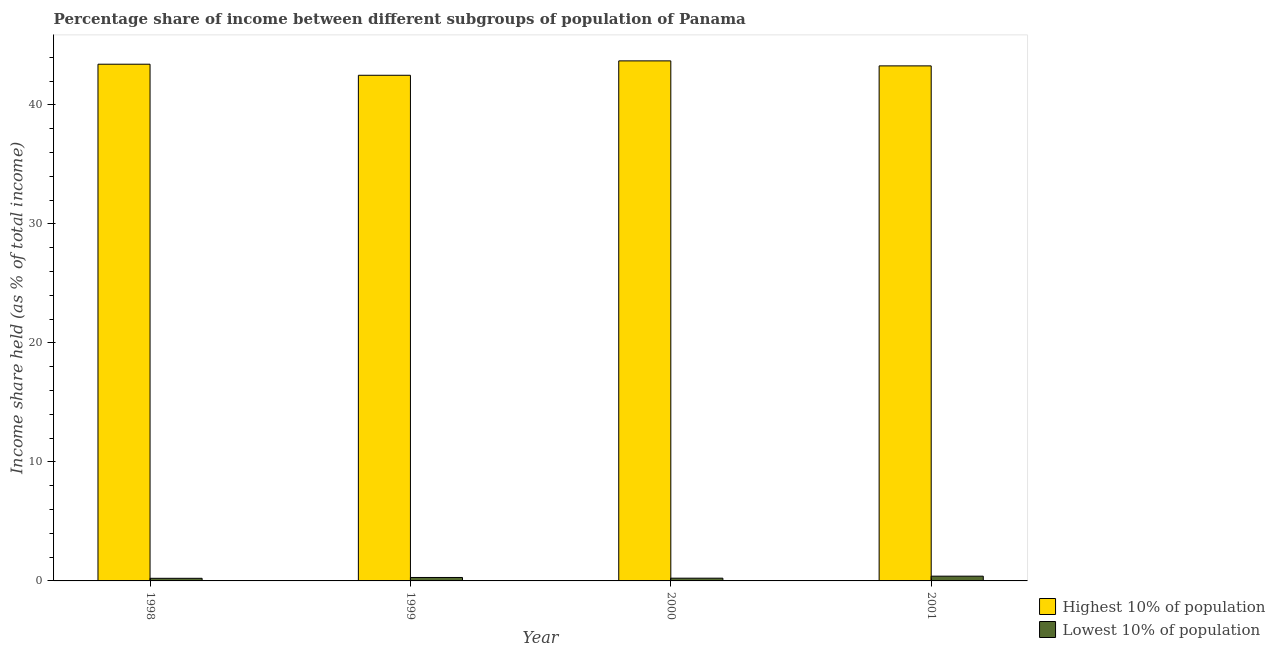How many different coloured bars are there?
Offer a terse response. 2. Are the number of bars on each tick of the X-axis equal?
Ensure brevity in your answer.  Yes. Across all years, what is the maximum income share held by highest 10% of the population?
Your response must be concise. 43.7. Across all years, what is the minimum income share held by highest 10% of the population?
Give a very brief answer. 42.49. In which year was the income share held by lowest 10% of the population maximum?
Keep it short and to the point. 2001. In which year was the income share held by highest 10% of the population minimum?
Make the answer very short. 1999. What is the total income share held by lowest 10% of the population in the graph?
Offer a very short reply. 1.14. What is the difference between the income share held by lowest 10% of the population in 1998 and that in 2000?
Your answer should be very brief. -0.01. What is the difference between the income share held by lowest 10% of the population in 1998 and the income share held by highest 10% of the population in 2000?
Keep it short and to the point. -0.01. What is the average income share held by highest 10% of the population per year?
Provide a succinct answer. 43.22. What is the ratio of the income share held by highest 10% of the population in 1998 to that in 2001?
Provide a short and direct response. 1. Is the income share held by highest 10% of the population in 2000 less than that in 2001?
Ensure brevity in your answer.  No. Is the difference between the income share held by lowest 10% of the population in 1999 and 2000 greater than the difference between the income share held by highest 10% of the population in 1999 and 2000?
Your answer should be very brief. No. What is the difference between the highest and the second highest income share held by lowest 10% of the population?
Ensure brevity in your answer.  0.11. What is the difference between the highest and the lowest income share held by highest 10% of the population?
Provide a succinct answer. 1.21. In how many years, is the income share held by highest 10% of the population greater than the average income share held by highest 10% of the population taken over all years?
Offer a terse response. 3. What does the 2nd bar from the left in 2000 represents?
Offer a very short reply. Lowest 10% of population. What does the 1st bar from the right in 2000 represents?
Provide a succinct answer. Lowest 10% of population. How many bars are there?
Your answer should be very brief. 8. Are all the bars in the graph horizontal?
Offer a terse response. No. How many legend labels are there?
Give a very brief answer. 2. How are the legend labels stacked?
Your answer should be very brief. Vertical. What is the title of the graph?
Your response must be concise. Percentage share of income between different subgroups of population of Panama. What is the label or title of the Y-axis?
Provide a short and direct response. Income share held (as % of total income). What is the Income share held (as % of total income) in Highest 10% of population in 1998?
Offer a very short reply. 43.42. What is the Income share held (as % of total income) of Lowest 10% of population in 1998?
Your answer should be very brief. 0.22. What is the Income share held (as % of total income) of Highest 10% of population in 1999?
Your answer should be compact. 42.49. What is the Income share held (as % of total income) of Lowest 10% of population in 1999?
Keep it short and to the point. 0.29. What is the Income share held (as % of total income) in Highest 10% of population in 2000?
Your response must be concise. 43.7. What is the Income share held (as % of total income) in Lowest 10% of population in 2000?
Offer a very short reply. 0.23. What is the Income share held (as % of total income) in Highest 10% of population in 2001?
Make the answer very short. 43.28. What is the Income share held (as % of total income) of Lowest 10% of population in 2001?
Your answer should be compact. 0.4. Across all years, what is the maximum Income share held (as % of total income) in Highest 10% of population?
Make the answer very short. 43.7. Across all years, what is the maximum Income share held (as % of total income) in Lowest 10% of population?
Give a very brief answer. 0.4. Across all years, what is the minimum Income share held (as % of total income) of Highest 10% of population?
Provide a succinct answer. 42.49. Across all years, what is the minimum Income share held (as % of total income) in Lowest 10% of population?
Your answer should be compact. 0.22. What is the total Income share held (as % of total income) in Highest 10% of population in the graph?
Your answer should be compact. 172.89. What is the total Income share held (as % of total income) in Lowest 10% of population in the graph?
Offer a terse response. 1.14. What is the difference between the Income share held (as % of total income) of Highest 10% of population in 1998 and that in 1999?
Give a very brief answer. 0.93. What is the difference between the Income share held (as % of total income) in Lowest 10% of population in 1998 and that in 1999?
Offer a terse response. -0.07. What is the difference between the Income share held (as % of total income) of Highest 10% of population in 1998 and that in 2000?
Your response must be concise. -0.28. What is the difference between the Income share held (as % of total income) in Lowest 10% of population in 1998 and that in 2000?
Provide a short and direct response. -0.01. What is the difference between the Income share held (as % of total income) of Highest 10% of population in 1998 and that in 2001?
Provide a succinct answer. 0.14. What is the difference between the Income share held (as % of total income) of Lowest 10% of population in 1998 and that in 2001?
Your answer should be very brief. -0.18. What is the difference between the Income share held (as % of total income) of Highest 10% of population in 1999 and that in 2000?
Give a very brief answer. -1.21. What is the difference between the Income share held (as % of total income) of Lowest 10% of population in 1999 and that in 2000?
Your answer should be compact. 0.06. What is the difference between the Income share held (as % of total income) of Highest 10% of population in 1999 and that in 2001?
Provide a short and direct response. -0.79. What is the difference between the Income share held (as % of total income) in Lowest 10% of population in 1999 and that in 2001?
Ensure brevity in your answer.  -0.11. What is the difference between the Income share held (as % of total income) of Highest 10% of population in 2000 and that in 2001?
Ensure brevity in your answer.  0.42. What is the difference between the Income share held (as % of total income) of Lowest 10% of population in 2000 and that in 2001?
Make the answer very short. -0.17. What is the difference between the Income share held (as % of total income) in Highest 10% of population in 1998 and the Income share held (as % of total income) in Lowest 10% of population in 1999?
Your answer should be compact. 43.13. What is the difference between the Income share held (as % of total income) of Highest 10% of population in 1998 and the Income share held (as % of total income) of Lowest 10% of population in 2000?
Keep it short and to the point. 43.19. What is the difference between the Income share held (as % of total income) in Highest 10% of population in 1998 and the Income share held (as % of total income) in Lowest 10% of population in 2001?
Your answer should be compact. 43.02. What is the difference between the Income share held (as % of total income) of Highest 10% of population in 1999 and the Income share held (as % of total income) of Lowest 10% of population in 2000?
Make the answer very short. 42.26. What is the difference between the Income share held (as % of total income) in Highest 10% of population in 1999 and the Income share held (as % of total income) in Lowest 10% of population in 2001?
Provide a short and direct response. 42.09. What is the difference between the Income share held (as % of total income) of Highest 10% of population in 2000 and the Income share held (as % of total income) of Lowest 10% of population in 2001?
Offer a terse response. 43.3. What is the average Income share held (as % of total income) of Highest 10% of population per year?
Ensure brevity in your answer.  43.22. What is the average Income share held (as % of total income) of Lowest 10% of population per year?
Your answer should be compact. 0.28. In the year 1998, what is the difference between the Income share held (as % of total income) in Highest 10% of population and Income share held (as % of total income) in Lowest 10% of population?
Your response must be concise. 43.2. In the year 1999, what is the difference between the Income share held (as % of total income) of Highest 10% of population and Income share held (as % of total income) of Lowest 10% of population?
Your answer should be compact. 42.2. In the year 2000, what is the difference between the Income share held (as % of total income) of Highest 10% of population and Income share held (as % of total income) of Lowest 10% of population?
Keep it short and to the point. 43.47. In the year 2001, what is the difference between the Income share held (as % of total income) in Highest 10% of population and Income share held (as % of total income) in Lowest 10% of population?
Keep it short and to the point. 42.88. What is the ratio of the Income share held (as % of total income) of Highest 10% of population in 1998 to that in 1999?
Your answer should be compact. 1.02. What is the ratio of the Income share held (as % of total income) of Lowest 10% of population in 1998 to that in 1999?
Give a very brief answer. 0.76. What is the ratio of the Income share held (as % of total income) in Lowest 10% of population in 1998 to that in 2000?
Provide a succinct answer. 0.96. What is the ratio of the Income share held (as % of total income) of Lowest 10% of population in 1998 to that in 2001?
Your response must be concise. 0.55. What is the ratio of the Income share held (as % of total income) of Highest 10% of population in 1999 to that in 2000?
Make the answer very short. 0.97. What is the ratio of the Income share held (as % of total income) of Lowest 10% of population in 1999 to that in 2000?
Give a very brief answer. 1.26. What is the ratio of the Income share held (as % of total income) of Highest 10% of population in 1999 to that in 2001?
Make the answer very short. 0.98. What is the ratio of the Income share held (as % of total income) in Lowest 10% of population in 1999 to that in 2001?
Make the answer very short. 0.72. What is the ratio of the Income share held (as % of total income) in Highest 10% of population in 2000 to that in 2001?
Your answer should be compact. 1.01. What is the ratio of the Income share held (as % of total income) in Lowest 10% of population in 2000 to that in 2001?
Offer a very short reply. 0.57. What is the difference between the highest and the second highest Income share held (as % of total income) of Highest 10% of population?
Provide a succinct answer. 0.28. What is the difference between the highest and the second highest Income share held (as % of total income) in Lowest 10% of population?
Your answer should be compact. 0.11. What is the difference between the highest and the lowest Income share held (as % of total income) in Highest 10% of population?
Provide a short and direct response. 1.21. What is the difference between the highest and the lowest Income share held (as % of total income) in Lowest 10% of population?
Offer a terse response. 0.18. 